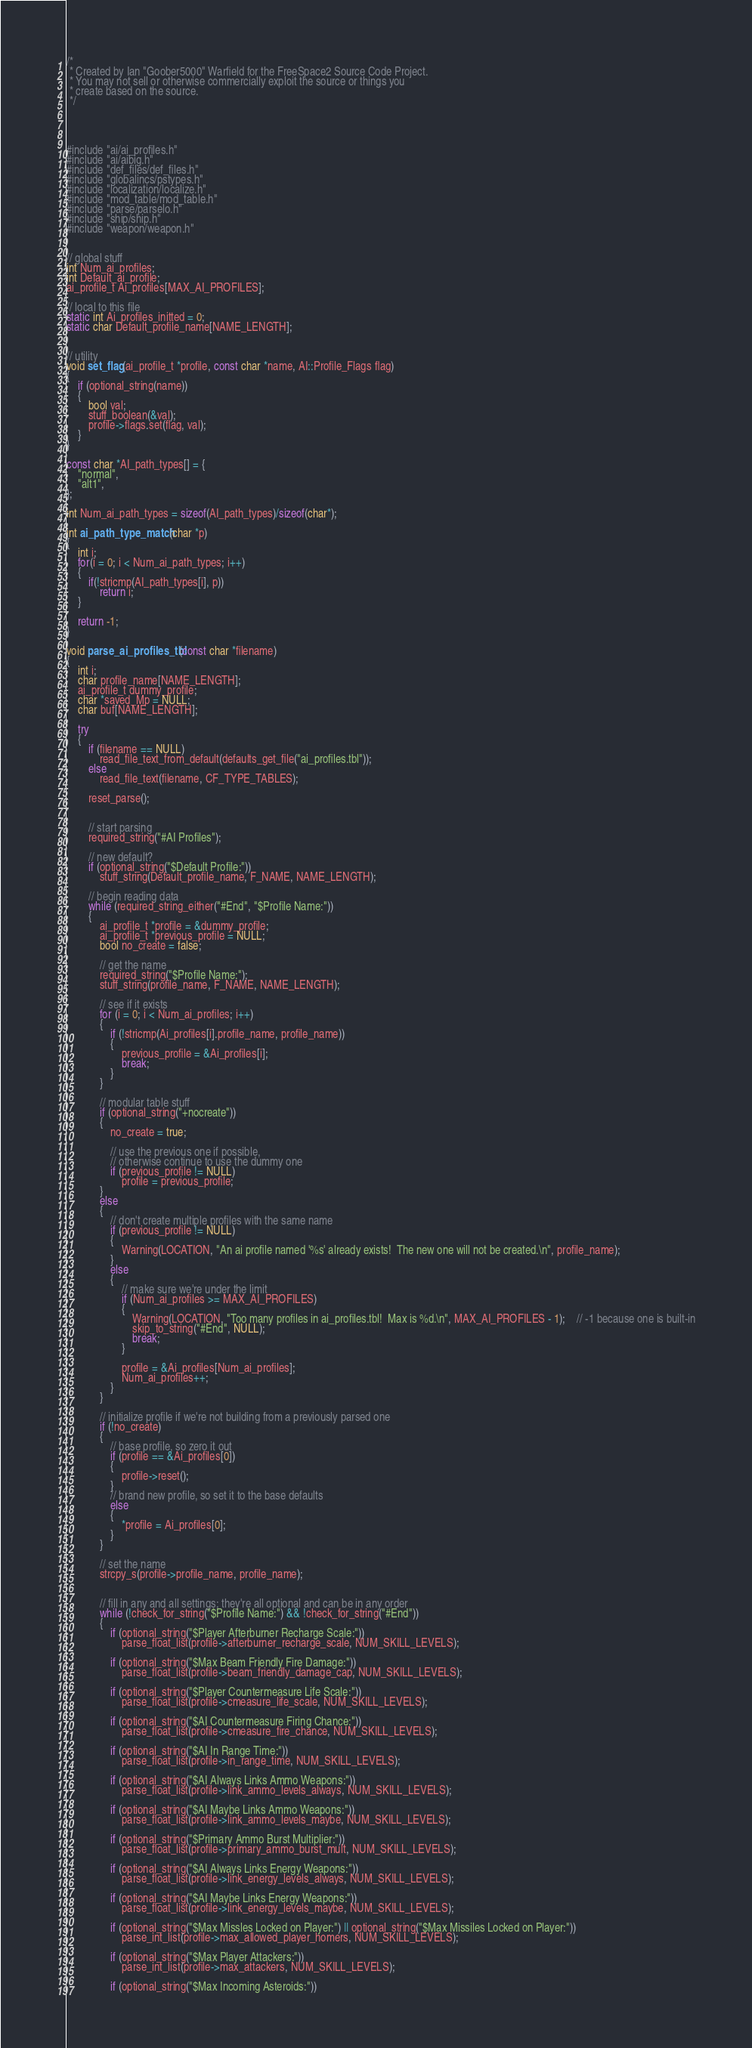Convert code to text. <code><loc_0><loc_0><loc_500><loc_500><_C++_>/*
 * Created by Ian "Goober5000" Warfield for the FreeSpace2 Source Code Project.
 * You may not sell or otherwise commercially exploit the source or things you
 * create based on the source.
 */




#include "ai/ai_profiles.h"
#include "ai/aibig.h"
#include "def_files/def_files.h"
#include "globalincs/pstypes.h"
#include "localization/localize.h"
#include "mod_table/mod_table.h"
#include "parse/parselo.h"
#include "ship/ship.h"
#include "weapon/weapon.h"


// global stuff
int Num_ai_profiles;
int Default_ai_profile;
ai_profile_t Ai_profiles[MAX_AI_PROFILES];

// local to this file
static int Ai_profiles_initted = 0;
static char Default_profile_name[NAME_LENGTH];


// utility
void set_flag(ai_profile_t *profile, const char *name, AI::Profile_Flags flag)
{
	if (optional_string(name))
	{
		bool val;
		stuff_boolean(&val);
        profile->flags.set(flag, val);
	}
}

const char *AI_path_types[] = {
	"normal",
	"alt1",
};

int Num_ai_path_types = sizeof(AI_path_types)/sizeof(char*);

int ai_path_type_match(char *p)
{
	int i;
	for(i = 0; i < Num_ai_path_types; i++)
	{
		if(!stricmp(AI_path_types[i], p))
			return i;
	}

	return -1;
}

void parse_ai_profiles_tbl(const char *filename)
{
	int i;
	char profile_name[NAME_LENGTH];
	ai_profile_t dummy_profile;
	char *saved_Mp = NULL;
	char buf[NAME_LENGTH];

	try
	{
		if (filename == NULL)
			read_file_text_from_default(defaults_get_file("ai_profiles.tbl"));
		else
			read_file_text(filename, CF_TYPE_TABLES);

		reset_parse();


		// start parsing
		required_string("#AI Profiles");

		// new default?
		if (optional_string("$Default Profile:"))
			stuff_string(Default_profile_name, F_NAME, NAME_LENGTH);

		// begin reading data
		while (required_string_either("#End", "$Profile Name:"))
		{
			ai_profile_t *profile = &dummy_profile;
			ai_profile_t *previous_profile = NULL;
			bool no_create = false;

			// get the name
			required_string("$Profile Name:");
			stuff_string(profile_name, F_NAME, NAME_LENGTH);

			// see if it exists
			for (i = 0; i < Num_ai_profiles; i++)
			{
				if (!stricmp(Ai_profiles[i].profile_name, profile_name))
				{
					previous_profile = &Ai_profiles[i];
					break;
				}
			}

			// modular table stuff
			if (optional_string("+nocreate"))
			{
				no_create = true;

				// use the previous one if possible,
				// otherwise continue to use the dummy one
				if (previous_profile != NULL)
					profile = previous_profile;
			}
			else
			{
				// don't create multiple profiles with the same name
				if (previous_profile != NULL)
				{
					Warning(LOCATION, "An ai profile named '%s' already exists!  The new one will not be created.\n", profile_name);
				}
				else
				{
					// make sure we're under the limit
					if (Num_ai_profiles >= MAX_AI_PROFILES)
					{
						Warning(LOCATION, "Too many profiles in ai_profiles.tbl!  Max is %d.\n", MAX_AI_PROFILES - 1);	// -1 because one is built-in
						skip_to_string("#End", NULL);
						break;
					}

					profile = &Ai_profiles[Num_ai_profiles];
					Num_ai_profiles++;
				}
			}

			// initialize profile if we're not building from a previously parsed one
			if (!no_create)
			{
				// base profile, so zero it out
				if (profile == &Ai_profiles[0])
				{
                    profile->reset();
				}
				// brand new profile, so set it to the base defaults
				else
				{
                    *profile = Ai_profiles[0];
				}
			}

			// set the name
			strcpy_s(profile->profile_name, profile_name);


			// fill in any and all settings; they're all optional and can be in any order
			while (!check_for_string("$Profile Name:") && !check_for_string("#End"))
			{
				if (optional_string("$Player Afterburner Recharge Scale:"))
					parse_float_list(profile->afterburner_recharge_scale, NUM_SKILL_LEVELS);

				if (optional_string("$Max Beam Friendly Fire Damage:"))
					parse_float_list(profile->beam_friendly_damage_cap, NUM_SKILL_LEVELS);

				if (optional_string("$Player Countermeasure Life Scale:"))
					parse_float_list(profile->cmeasure_life_scale, NUM_SKILL_LEVELS);

				if (optional_string("$AI Countermeasure Firing Chance:"))
					parse_float_list(profile->cmeasure_fire_chance, NUM_SKILL_LEVELS);

				if (optional_string("$AI In Range Time:"))
					parse_float_list(profile->in_range_time, NUM_SKILL_LEVELS);

				if (optional_string("$AI Always Links Ammo Weapons:"))
					parse_float_list(profile->link_ammo_levels_always, NUM_SKILL_LEVELS);

				if (optional_string("$AI Maybe Links Ammo Weapons:"))
					parse_float_list(profile->link_ammo_levels_maybe, NUM_SKILL_LEVELS);

				if (optional_string("$Primary Ammo Burst Multiplier:"))
					parse_float_list(profile->primary_ammo_burst_mult, NUM_SKILL_LEVELS);

				if (optional_string("$AI Always Links Energy Weapons:"))
					parse_float_list(profile->link_energy_levels_always, NUM_SKILL_LEVELS);

				if (optional_string("$AI Maybe Links Energy Weapons:"))
					parse_float_list(profile->link_energy_levels_maybe, NUM_SKILL_LEVELS);

				if (optional_string("$Max Missles Locked on Player:") || optional_string("$Max Missiles Locked on Player:"))
					parse_int_list(profile->max_allowed_player_homers, NUM_SKILL_LEVELS);

				if (optional_string("$Max Player Attackers:"))
					parse_int_list(profile->max_attackers, NUM_SKILL_LEVELS);

				if (optional_string("$Max Incoming Asteroids:"))</code> 